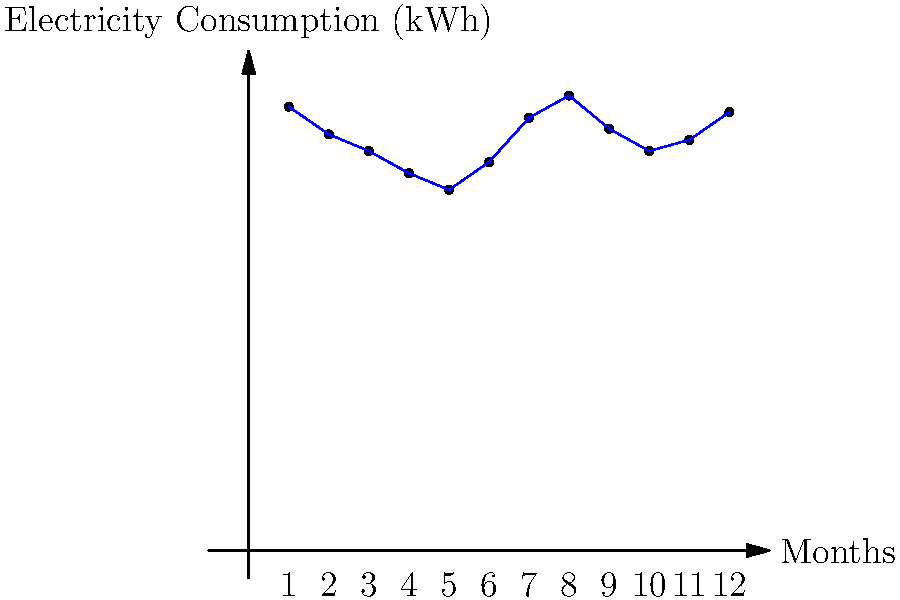Based on the line graph showing monthly electricity consumption for Benchwarmers' building, what would be a reasonable estimate for the electricity consumption in kWh for the upcoming month (month 13)? To estimate the electricity consumption for the upcoming month, we need to analyze the trend and patterns in the given data:

1. Observe the overall trend: The consumption fluctuates throughout the year but shows a general pattern.

2. Identify seasonality: There's a noticeable increase in consumption during summer months (around months 7-8) and winter months (around months 12-1).

3. Compare with the previous year: Month 13 would correspond to the same month as month 1 in the previous year.

4. Look at recent months: Consider the trend of the last few months (10-12) to gauge the current direction.

5. Make an informed estimate:
   - Month 1 consumption: 8000 kWh
   - Recent months trend: Slight increase from months 10-12
   - Seasonal factor: Similar to month 1 (winter month)

Considering these factors, a reasonable estimate would be slightly higher than month 1 of the previous year, accounting for the recent upward trend.

A plausible estimate would be around 8100-8200 kWh for month 13.
Answer: ~8100-8200 kWh 